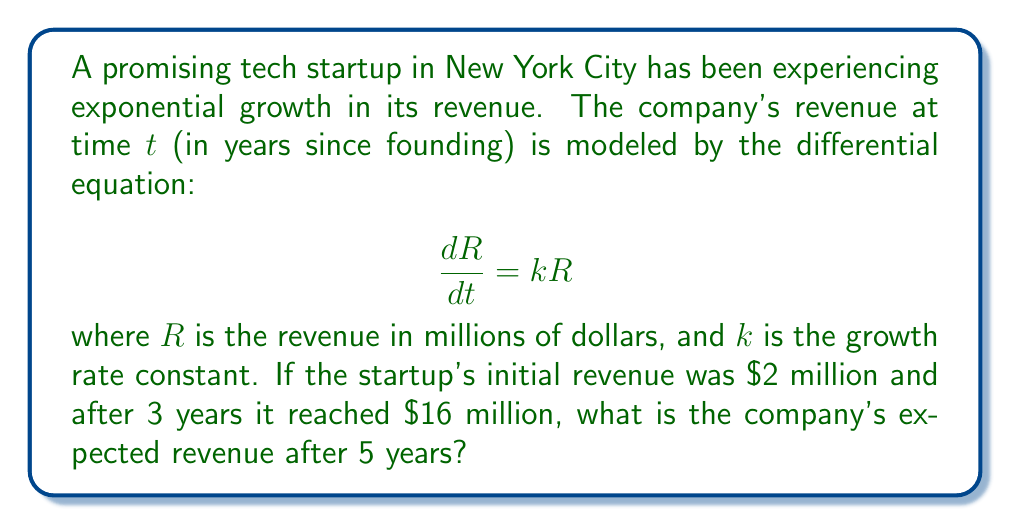Provide a solution to this math problem. Let's solve this problem step by step:

1) The general solution to the differential equation $\frac{dR}{dt} = kR$ is:

   $$R(t) = R_0e^{kt}$$

   where $R_0$ is the initial revenue.

2) We're given that $R_0 = 2$ million dollars.

3) We can find $k$ using the information that after 3 years, revenue was $16 million:

   $$16 = 2e^{3k}$$

4) Solving for $k$:

   $$e^{3k} = 8$$
   $$3k = \ln(8) = \ln(2^3) = 3\ln(2)$$
   $$k = \ln(2) \approx 0.693$$

5) Now we have the complete equation for revenue at time $t$:

   $$R(t) = 2e^{(\ln(2))t}$$

6) To find the revenue after 5 years, we substitute $t=5$:

   $$R(5) = 2e^{(\ln(2))5} = 2(2^5) = 2(32) = 64$$

Therefore, after 5 years, the expected revenue is $64 million dollars.
Answer: $64 million 